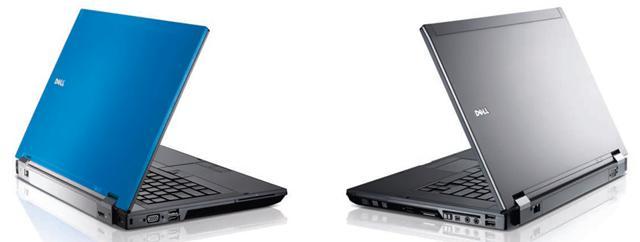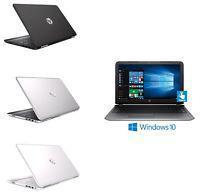The first image is the image on the left, the second image is the image on the right. Given the left and right images, does the statement "There are more devices in the image on the left than in the image on the right." hold true? Answer yes or no. No. The first image is the image on the left, the second image is the image on the right. For the images shown, is this caption "The right image contains exactly four laptop computers." true? Answer yes or no. Yes. 